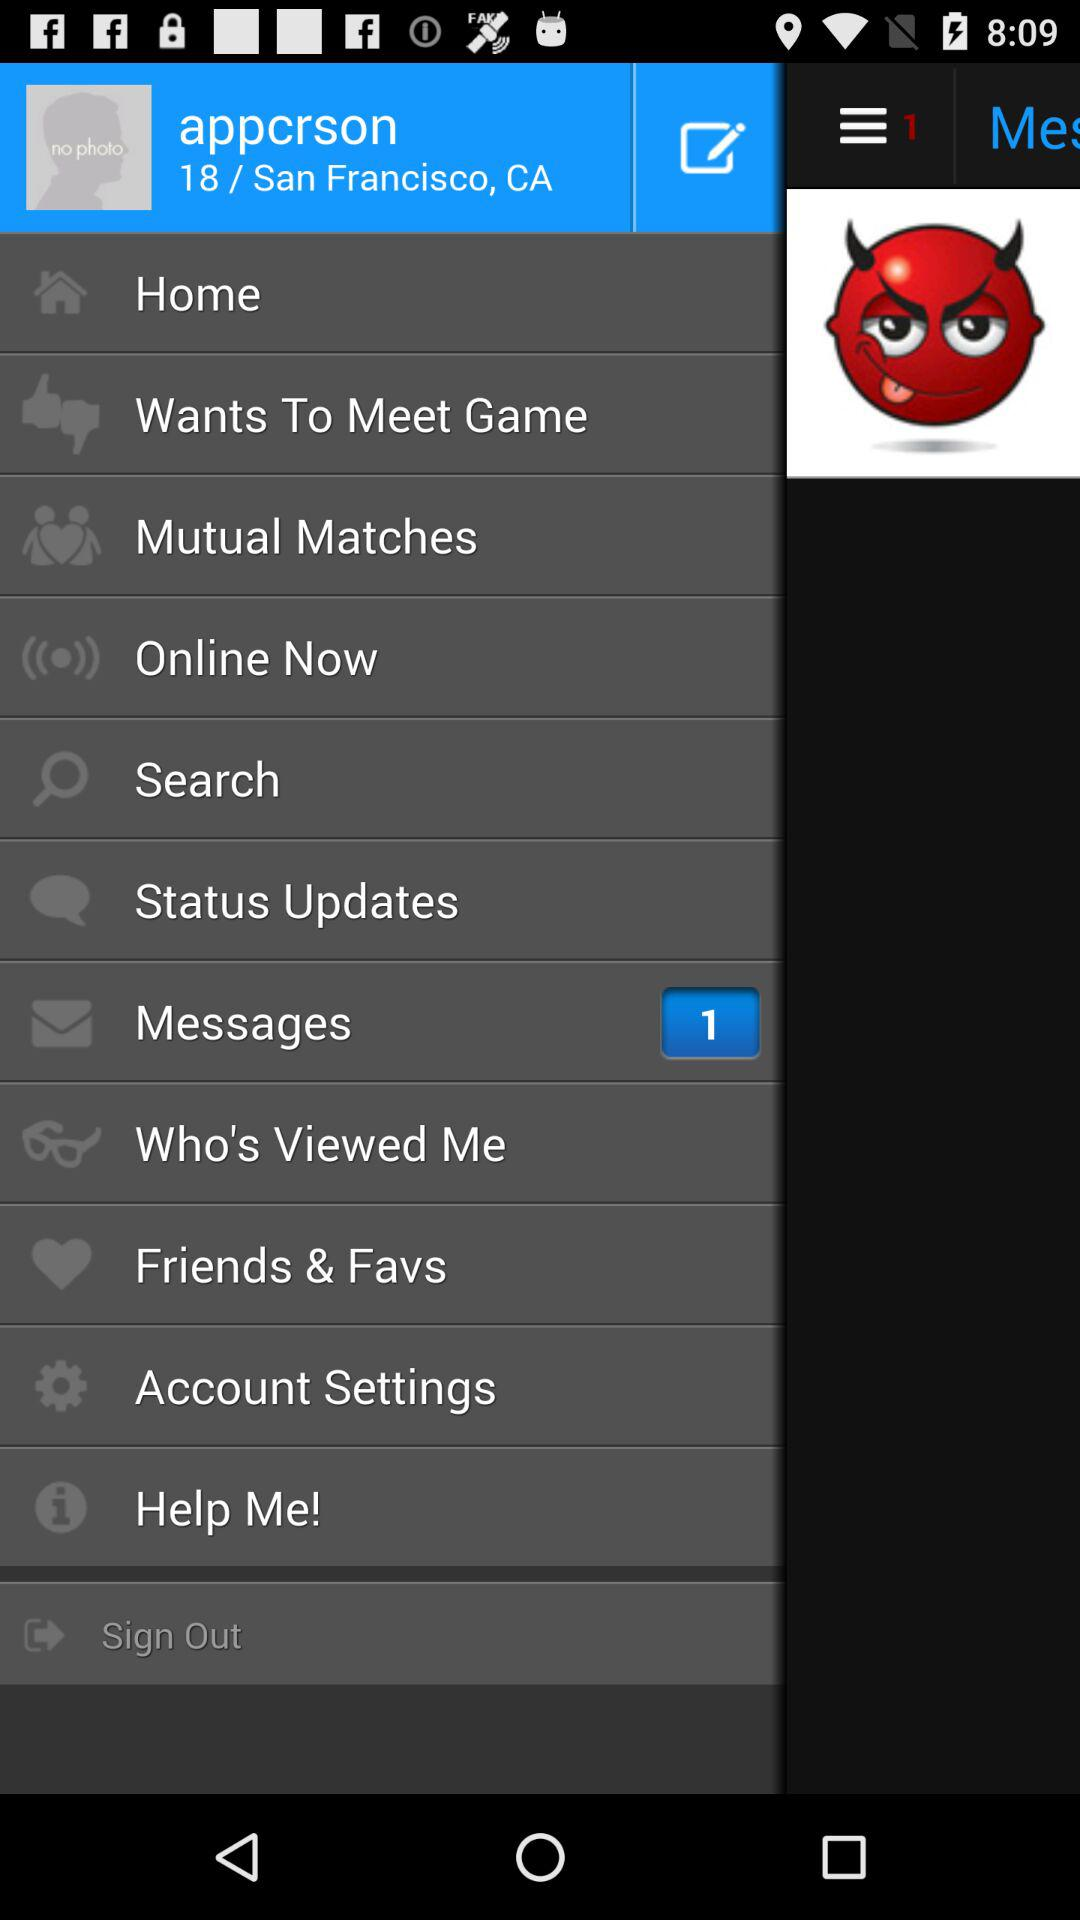What is the username? The username is "appcrson". 